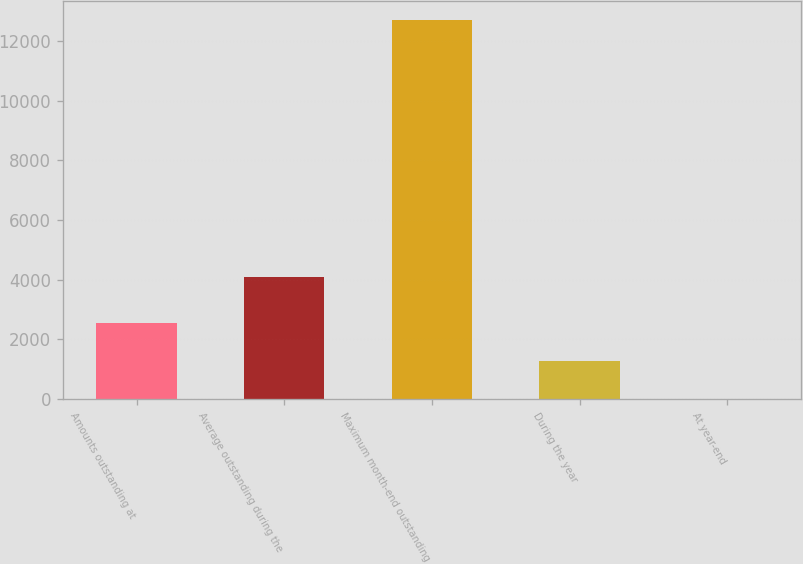<chart> <loc_0><loc_0><loc_500><loc_500><bar_chart><fcel>Amounts outstanding at<fcel>Average outstanding during the<fcel>Maximum month-end outstanding<fcel>During the year<fcel>At year-end<nl><fcel>2545.83<fcel>4097<fcel>12718<fcel>1274.31<fcel>2.79<nl></chart> 